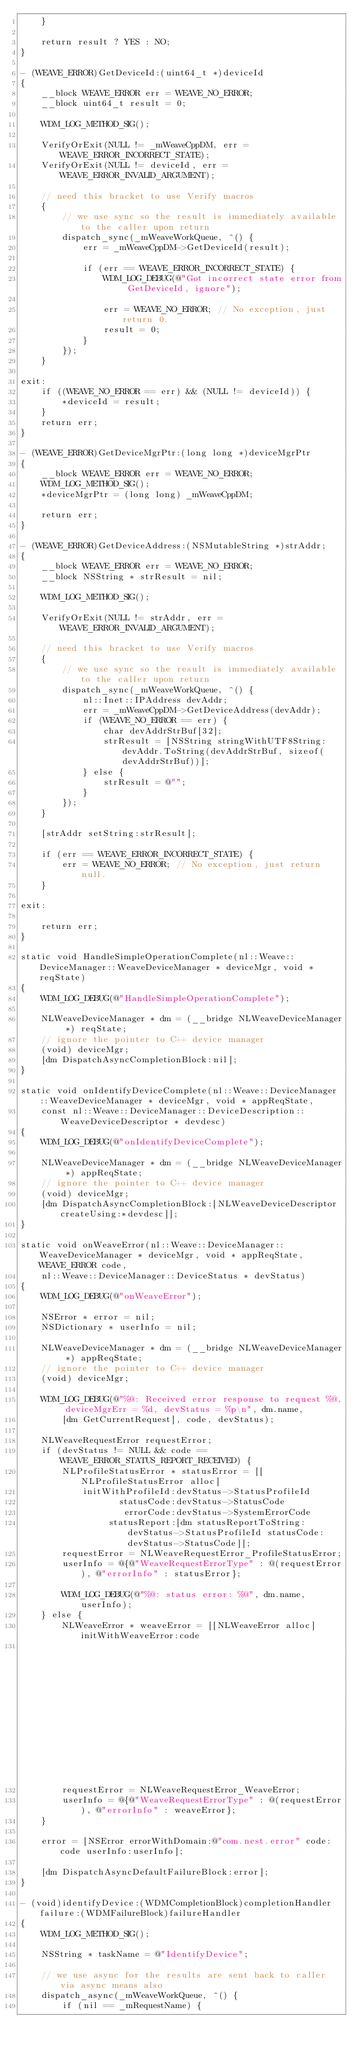<code> <loc_0><loc_0><loc_500><loc_500><_ObjectiveC_>    }

    return result ? YES : NO;
}

- (WEAVE_ERROR)GetDeviceId:(uint64_t *)deviceId
{
    __block WEAVE_ERROR err = WEAVE_NO_ERROR;
    __block uint64_t result = 0;

    WDM_LOG_METHOD_SIG();

    VerifyOrExit(NULL != _mWeaveCppDM, err = WEAVE_ERROR_INCORRECT_STATE);
    VerifyOrExit(NULL != deviceId, err = WEAVE_ERROR_INVALID_ARGUMENT);

    // need this bracket to use Verify macros
    {
        // we use sync so the result is immediately available to the caller upon return
        dispatch_sync(_mWeaveWorkQueue, ^() {
            err = _mWeaveCppDM->GetDeviceId(result);

            if (err == WEAVE_ERROR_INCORRECT_STATE) {
                WDM_LOG_DEBUG(@"Got incorrect state error from GetDeviceId, ignore");

                err = WEAVE_NO_ERROR; // No exception, just return 0.
                result = 0;
            }
        });
    }

exit:
    if ((WEAVE_NO_ERROR == err) && (NULL != deviceId)) {
        *deviceId = result;
    }
    return err;
}

- (WEAVE_ERROR)GetDeviceMgrPtr:(long long *)deviceMgrPtr
{
    __block WEAVE_ERROR err = WEAVE_NO_ERROR;
    WDM_LOG_METHOD_SIG();
    *deviceMgrPtr = (long long) _mWeaveCppDM;

    return err;
}

- (WEAVE_ERROR)GetDeviceAddress:(NSMutableString *)strAddr;
{
    __block WEAVE_ERROR err = WEAVE_NO_ERROR;
    __block NSString * strResult = nil;

    WDM_LOG_METHOD_SIG();

    VerifyOrExit(NULL != strAddr, err = WEAVE_ERROR_INVALID_ARGUMENT);

    // need this bracket to use Verify macros
    {
        // we use sync so the result is immediately available to the caller upon return
        dispatch_sync(_mWeaveWorkQueue, ^() {
            nl::Inet::IPAddress devAddr;
            err = _mWeaveCppDM->GetDeviceAddress(devAddr);
            if (WEAVE_NO_ERROR == err) {
                char devAddrStrBuf[32];
                strResult = [NSString stringWithUTF8String:devAddr.ToString(devAddrStrBuf, sizeof(devAddrStrBuf))];
            } else {
                strResult = @"";
            }
        });
    }

    [strAddr setString:strResult];

    if (err == WEAVE_ERROR_INCORRECT_STATE) {
        err = WEAVE_NO_ERROR; // No exception, just return null.
    }

exit:

    return err;
}

static void HandleSimpleOperationComplete(nl::Weave::DeviceManager::WeaveDeviceManager * deviceMgr, void * reqState)
{
    WDM_LOG_DEBUG(@"HandleSimpleOperationComplete");

    NLWeaveDeviceManager * dm = (__bridge NLWeaveDeviceManager *) reqState;
    // ignore the pointer to C++ device manager
    (void) deviceMgr;
    [dm DispatchAsyncCompletionBlock:nil];
}

static void onIdentifyDeviceComplete(nl::Weave::DeviceManager::WeaveDeviceManager * deviceMgr, void * appReqState,
    const nl::Weave::DeviceManager::DeviceDescription::WeaveDeviceDescriptor * devdesc)
{
    WDM_LOG_DEBUG(@"onIdentifyDeviceComplete");

    NLWeaveDeviceManager * dm = (__bridge NLWeaveDeviceManager *) appReqState;
    // ignore the pointer to C++ device manager
    (void) deviceMgr;
    [dm DispatchAsyncCompletionBlock:[NLWeaveDeviceDescriptor createUsing:*devdesc]];
}

static void onWeaveError(nl::Weave::DeviceManager::WeaveDeviceManager * deviceMgr, void * appReqState, WEAVE_ERROR code,
    nl::Weave::DeviceManager::DeviceStatus * devStatus)
{
    WDM_LOG_DEBUG(@"onWeaveError");

    NSError * error = nil;
    NSDictionary * userInfo = nil;

    NLWeaveDeviceManager * dm = (__bridge NLWeaveDeviceManager *) appReqState;
    // ignore the pointer to C++ device manager
    (void) deviceMgr;

    WDM_LOG_DEBUG(@"%@: Received error response to request %@, deviceMgrErr = %d, devStatus = %p\n", dm.name,
        [dm GetCurrentRequest], code, devStatus);

    NLWeaveRequestError requestError;
    if (devStatus != NULL && code == WEAVE_ERROR_STATUS_REPORT_RECEIVED) {
        NLProfileStatusError * statusError = [[NLProfileStatusError alloc]
            initWithProfileId:devStatus->StatusProfileId
                   statusCode:devStatus->StatusCode
                    errorCode:devStatus->SystemErrorCode
                 statusReport:[dm statusReportToString:devStatus->StatusProfileId statusCode:devStatus->StatusCode]];
        requestError = NLWeaveRequestError_ProfileStatusError;
        userInfo = @{@"WeaveRequestErrorType" : @(requestError), @"errorInfo" : statusError};

        WDM_LOG_DEBUG(@"%@: status error: %@", dm.name, userInfo);
    } else {
        NLWeaveError * weaveError = [[NLWeaveError alloc] initWithWeaveError:code
                                                                      report:[NSString stringWithUTF8String:nl::ErrorStr(code)]];
        requestError = NLWeaveRequestError_WeaveError;
        userInfo = @{@"WeaveRequestErrorType" : @(requestError), @"errorInfo" : weaveError};
    }

    error = [NSError errorWithDomain:@"com.nest.error" code:code userInfo:userInfo];

    [dm DispatchAsyncDefaultFailureBlock:error];
}

- (void)identifyDevice:(WDMCompletionBlock)completionHandler failure:(WDMFailureBlock)failureHandler
{
    WDM_LOG_METHOD_SIG();

    NSString * taskName = @"IdentifyDevice";

    // we use async for the results are sent back to caller via async means also
    dispatch_async(_mWeaveWorkQueue, ^() {
        if (nil == _mRequestName) {</code> 